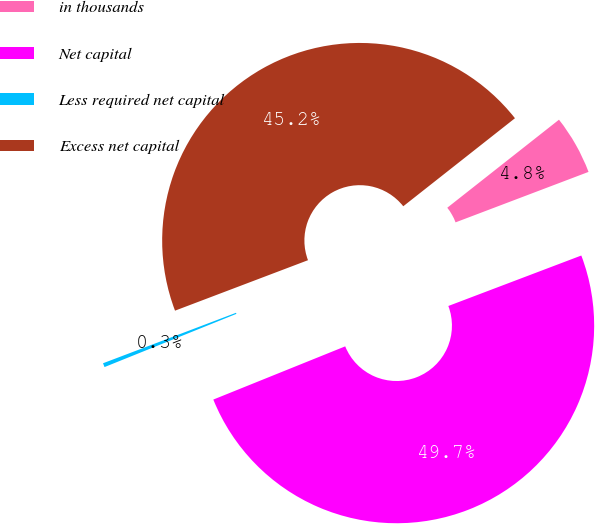<chart> <loc_0><loc_0><loc_500><loc_500><pie_chart><fcel>in thousands<fcel>Net capital<fcel>Less required net capital<fcel>Excess net capital<nl><fcel>4.85%<fcel>49.67%<fcel>0.33%<fcel>45.15%<nl></chart> 